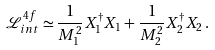Convert formula to latex. <formula><loc_0><loc_0><loc_500><loc_500>\mathcal { L } _ { i n t } ^ { 4 f } \simeq \frac { 1 } { M _ { 1 } ^ { 2 } } X _ { 1 } ^ { \dagger } X _ { 1 } + \frac { 1 } { M _ { 2 } ^ { 2 } } X _ { 2 } ^ { \dagger } X _ { 2 } \, .</formula> 